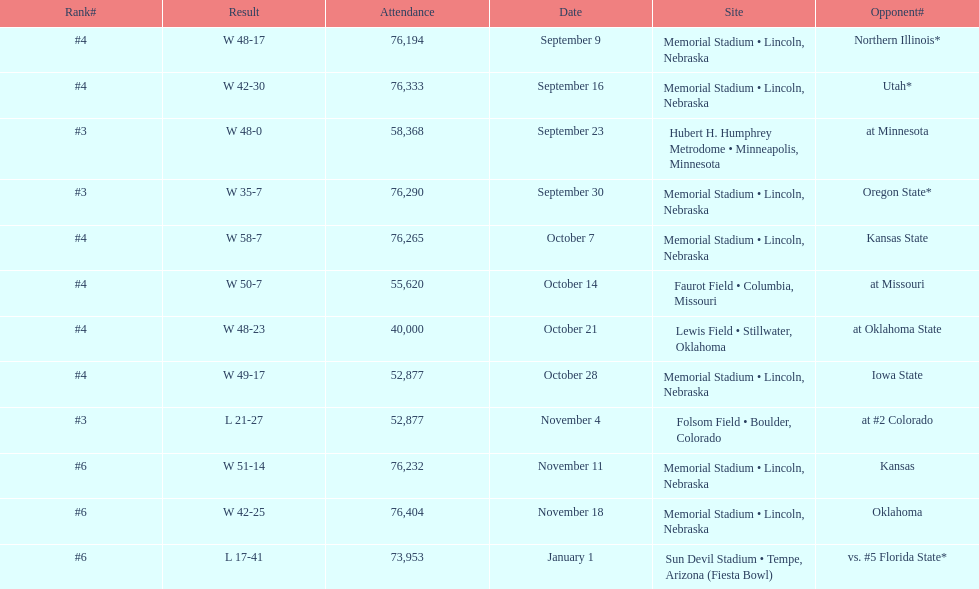Which month is listed the least on this chart? January. 